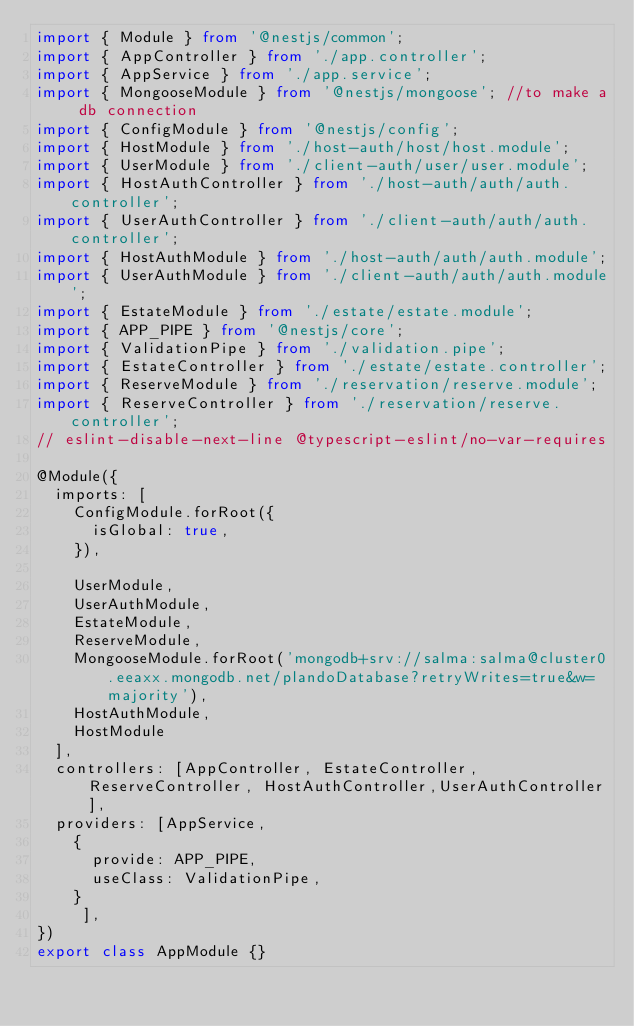Convert code to text. <code><loc_0><loc_0><loc_500><loc_500><_TypeScript_>import { Module } from '@nestjs/common';
import { AppController } from './app.controller';
import { AppService } from './app.service';
import { MongooseModule } from '@nestjs/mongoose'; //to make a db connection
import { ConfigModule } from '@nestjs/config'; 
import { HostModule } from './host-auth/host/host.module';
import { UserModule } from './client-auth/user/user.module';
import { HostAuthController } from './host-auth/auth/auth.controller';
import { UserAuthController } from './client-auth/auth/auth.controller';
import { HostAuthModule } from './host-auth/auth/auth.module';
import { UserAuthModule } from './client-auth/auth/auth.module';
import { EstateModule } from './estate/estate.module';
import { APP_PIPE } from '@nestjs/core';
import { ValidationPipe } from './validation.pipe'; 
import { EstateController } from './estate/estate.controller';
import { ReserveModule } from './reservation/reserve.module';
import { ReserveController } from './reservation/reserve.controller';
// eslint-disable-next-line @typescript-eslint/no-var-requires

@Module({
  imports: [
    ConfigModule.forRoot({
      isGlobal: true,
    }),
    
    UserModule,
    UserAuthModule,
    EstateModule,
    ReserveModule,
    MongooseModule.forRoot('mongodb+srv://salma:salma@cluster0.eeaxx.mongodb.net/plandoDatabase?retryWrites=true&w=majority'), 
    HostAuthModule, 
    HostModule
  ],
  controllers: [AppController, EstateController,  ReserveController, HostAuthController,UserAuthController],
  providers: [AppService,
    {
      provide: APP_PIPE,
      useClass: ValidationPipe,
    }
     ],
})
export class AppModule {}
</code> 